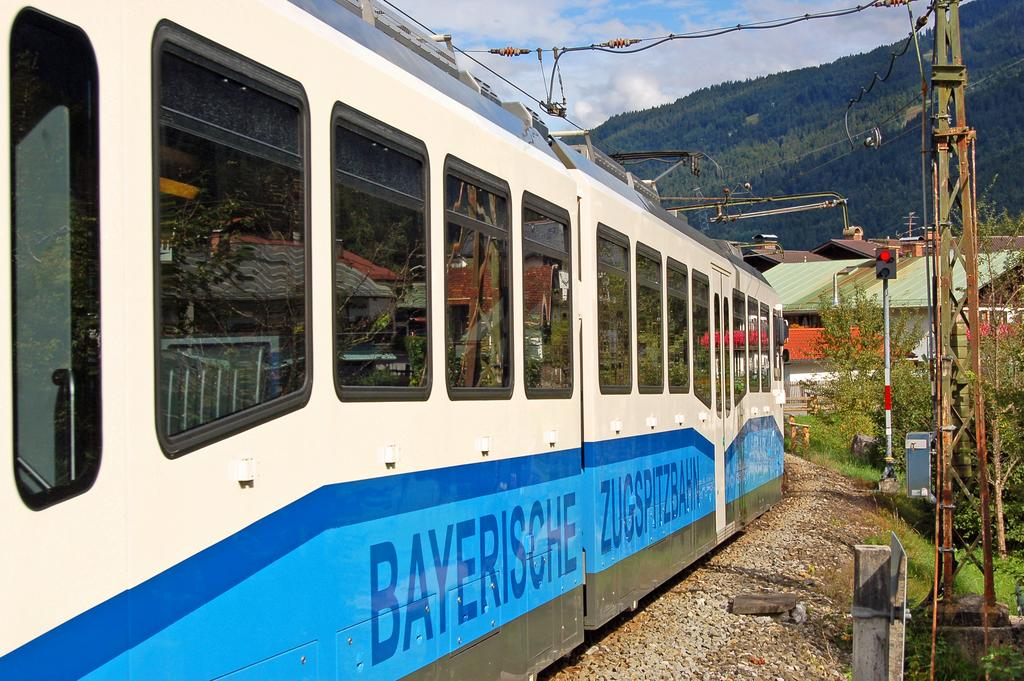Provide a one-sentence caption for the provided image. the word bayersche on the side of a train. 